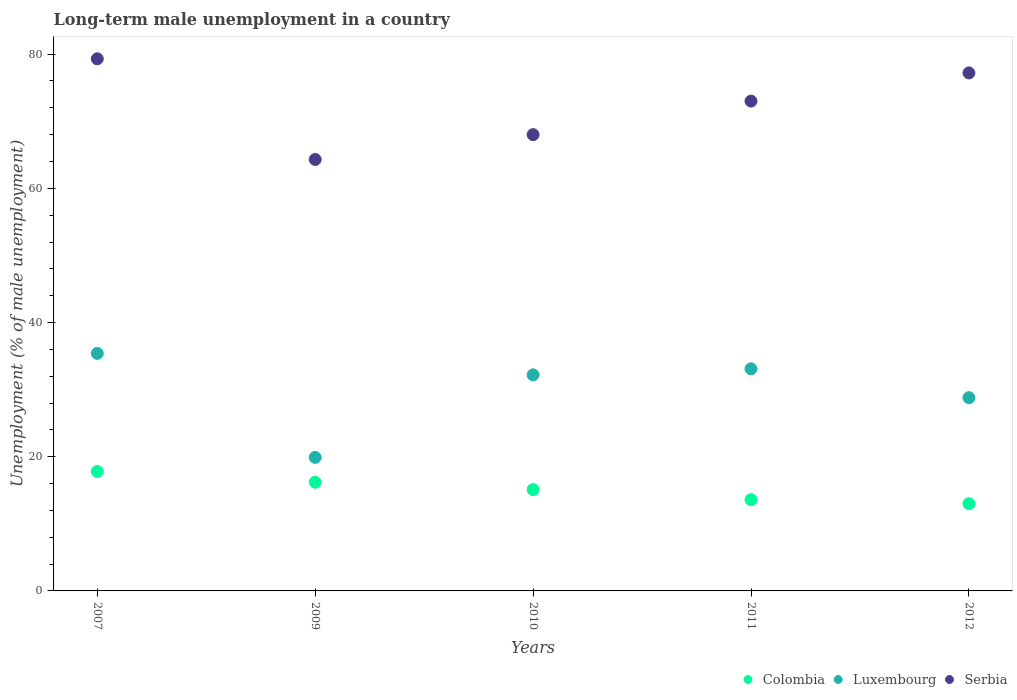Across all years, what is the maximum percentage of long-term unemployed male population in Serbia?
Your answer should be very brief. 79.3. Across all years, what is the minimum percentage of long-term unemployed male population in Luxembourg?
Give a very brief answer. 19.9. In which year was the percentage of long-term unemployed male population in Luxembourg minimum?
Your response must be concise. 2009. What is the total percentage of long-term unemployed male population in Colombia in the graph?
Your answer should be compact. 75.7. What is the difference between the percentage of long-term unemployed male population in Luxembourg in 2009 and that in 2012?
Make the answer very short. -8.9. What is the difference between the percentage of long-term unemployed male population in Colombia in 2011 and the percentage of long-term unemployed male population in Serbia in 2012?
Keep it short and to the point. -63.6. What is the average percentage of long-term unemployed male population in Luxembourg per year?
Ensure brevity in your answer.  29.88. In the year 2010, what is the difference between the percentage of long-term unemployed male population in Luxembourg and percentage of long-term unemployed male population in Serbia?
Your answer should be very brief. -35.8. What is the ratio of the percentage of long-term unemployed male population in Serbia in 2009 to that in 2011?
Your answer should be very brief. 0.88. Is the percentage of long-term unemployed male population in Colombia in 2007 less than that in 2012?
Your answer should be compact. No. Is the difference between the percentage of long-term unemployed male population in Luxembourg in 2009 and 2010 greater than the difference between the percentage of long-term unemployed male population in Serbia in 2009 and 2010?
Ensure brevity in your answer.  No. What is the difference between the highest and the second highest percentage of long-term unemployed male population in Colombia?
Your answer should be very brief. 1.6. What is the difference between the highest and the lowest percentage of long-term unemployed male population in Serbia?
Ensure brevity in your answer.  15. Is the sum of the percentage of long-term unemployed male population in Luxembourg in 2009 and 2010 greater than the maximum percentage of long-term unemployed male population in Serbia across all years?
Offer a very short reply. No. Is it the case that in every year, the sum of the percentage of long-term unemployed male population in Serbia and percentage of long-term unemployed male population in Colombia  is greater than the percentage of long-term unemployed male population in Luxembourg?
Ensure brevity in your answer.  Yes. What is the difference between two consecutive major ticks on the Y-axis?
Offer a very short reply. 20. Are the values on the major ticks of Y-axis written in scientific E-notation?
Provide a short and direct response. No. Does the graph contain grids?
Make the answer very short. No. Where does the legend appear in the graph?
Offer a very short reply. Bottom right. How many legend labels are there?
Provide a succinct answer. 3. How are the legend labels stacked?
Your answer should be compact. Horizontal. What is the title of the graph?
Give a very brief answer. Long-term male unemployment in a country. Does "Norway" appear as one of the legend labels in the graph?
Provide a short and direct response. No. What is the label or title of the Y-axis?
Make the answer very short. Unemployment (% of male unemployment). What is the Unemployment (% of male unemployment) in Colombia in 2007?
Give a very brief answer. 17.8. What is the Unemployment (% of male unemployment) in Luxembourg in 2007?
Your response must be concise. 35.4. What is the Unemployment (% of male unemployment) of Serbia in 2007?
Your answer should be compact. 79.3. What is the Unemployment (% of male unemployment) of Colombia in 2009?
Give a very brief answer. 16.2. What is the Unemployment (% of male unemployment) in Luxembourg in 2009?
Offer a terse response. 19.9. What is the Unemployment (% of male unemployment) of Serbia in 2009?
Provide a succinct answer. 64.3. What is the Unemployment (% of male unemployment) in Colombia in 2010?
Your response must be concise. 15.1. What is the Unemployment (% of male unemployment) of Luxembourg in 2010?
Offer a terse response. 32.2. What is the Unemployment (% of male unemployment) of Colombia in 2011?
Make the answer very short. 13.6. What is the Unemployment (% of male unemployment) in Luxembourg in 2011?
Provide a short and direct response. 33.1. What is the Unemployment (% of male unemployment) in Serbia in 2011?
Ensure brevity in your answer.  73. What is the Unemployment (% of male unemployment) of Colombia in 2012?
Keep it short and to the point. 13. What is the Unemployment (% of male unemployment) in Luxembourg in 2012?
Your answer should be compact. 28.8. What is the Unemployment (% of male unemployment) in Serbia in 2012?
Make the answer very short. 77.2. Across all years, what is the maximum Unemployment (% of male unemployment) in Colombia?
Offer a very short reply. 17.8. Across all years, what is the maximum Unemployment (% of male unemployment) of Luxembourg?
Offer a terse response. 35.4. Across all years, what is the maximum Unemployment (% of male unemployment) of Serbia?
Ensure brevity in your answer.  79.3. Across all years, what is the minimum Unemployment (% of male unemployment) in Colombia?
Your answer should be very brief. 13. Across all years, what is the minimum Unemployment (% of male unemployment) in Luxembourg?
Keep it short and to the point. 19.9. Across all years, what is the minimum Unemployment (% of male unemployment) of Serbia?
Ensure brevity in your answer.  64.3. What is the total Unemployment (% of male unemployment) in Colombia in the graph?
Offer a very short reply. 75.7. What is the total Unemployment (% of male unemployment) of Luxembourg in the graph?
Provide a succinct answer. 149.4. What is the total Unemployment (% of male unemployment) in Serbia in the graph?
Offer a very short reply. 361.8. What is the difference between the Unemployment (% of male unemployment) of Colombia in 2007 and that in 2009?
Ensure brevity in your answer.  1.6. What is the difference between the Unemployment (% of male unemployment) in Serbia in 2007 and that in 2009?
Ensure brevity in your answer.  15. What is the difference between the Unemployment (% of male unemployment) of Colombia in 2007 and that in 2010?
Keep it short and to the point. 2.7. What is the difference between the Unemployment (% of male unemployment) of Luxembourg in 2007 and that in 2010?
Offer a very short reply. 3.2. What is the difference between the Unemployment (% of male unemployment) in Serbia in 2007 and that in 2010?
Offer a very short reply. 11.3. What is the difference between the Unemployment (% of male unemployment) in Luxembourg in 2007 and that in 2011?
Offer a very short reply. 2.3. What is the difference between the Unemployment (% of male unemployment) of Serbia in 2007 and that in 2012?
Offer a terse response. 2.1. What is the difference between the Unemployment (% of male unemployment) of Luxembourg in 2009 and that in 2011?
Provide a short and direct response. -13.2. What is the difference between the Unemployment (% of male unemployment) in Serbia in 2009 and that in 2011?
Make the answer very short. -8.7. What is the difference between the Unemployment (% of male unemployment) of Luxembourg in 2010 and that in 2011?
Offer a very short reply. -0.9. What is the difference between the Unemployment (% of male unemployment) in Serbia in 2010 and that in 2011?
Keep it short and to the point. -5. What is the difference between the Unemployment (% of male unemployment) in Luxembourg in 2010 and that in 2012?
Your response must be concise. 3.4. What is the difference between the Unemployment (% of male unemployment) in Colombia in 2011 and that in 2012?
Provide a short and direct response. 0.6. What is the difference between the Unemployment (% of male unemployment) of Luxembourg in 2011 and that in 2012?
Provide a short and direct response. 4.3. What is the difference between the Unemployment (% of male unemployment) of Serbia in 2011 and that in 2012?
Give a very brief answer. -4.2. What is the difference between the Unemployment (% of male unemployment) in Colombia in 2007 and the Unemployment (% of male unemployment) in Luxembourg in 2009?
Your answer should be very brief. -2.1. What is the difference between the Unemployment (% of male unemployment) of Colombia in 2007 and the Unemployment (% of male unemployment) of Serbia in 2009?
Ensure brevity in your answer.  -46.5. What is the difference between the Unemployment (% of male unemployment) in Luxembourg in 2007 and the Unemployment (% of male unemployment) in Serbia in 2009?
Keep it short and to the point. -28.9. What is the difference between the Unemployment (% of male unemployment) in Colombia in 2007 and the Unemployment (% of male unemployment) in Luxembourg in 2010?
Your answer should be compact. -14.4. What is the difference between the Unemployment (% of male unemployment) in Colombia in 2007 and the Unemployment (% of male unemployment) in Serbia in 2010?
Offer a very short reply. -50.2. What is the difference between the Unemployment (% of male unemployment) in Luxembourg in 2007 and the Unemployment (% of male unemployment) in Serbia in 2010?
Keep it short and to the point. -32.6. What is the difference between the Unemployment (% of male unemployment) of Colombia in 2007 and the Unemployment (% of male unemployment) of Luxembourg in 2011?
Offer a very short reply. -15.3. What is the difference between the Unemployment (% of male unemployment) of Colombia in 2007 and the Unemployment (% of male unemployment) of Serbia in 2011?
Provide a short and direct response. -55.2. What is the difference between the Unemployment (% of male unemployment) of Luxembourg in 2007 and the Unemployment (% of male unemployment) of Serbia in 2011?
Offer a terse response. -37.6. What is the difference between the Unemployment (% of male unemployment) in Colombia in 2007 and the Unemployment (% of male unemployment) in Serbia in 2012?
Offer a terse response. -59.4. What is the difference between the Unemployment (% of male unemployment) of Luxembourg in 2007 and the Unemployment (% of male unemployment) of Serbia in 2012?
Your answer should be compact. -41.8. What is the difference between the Unemployment (% of male unemployment) of Colombia in 2009 and the Unemployment (% of male unemployment) of Serbia in 2010?
Make the answer very short. -51.8. What is the difference between the Unemployment (% of male unemployment) of Luxembourg in 2009 and the Unemployment (% of male unemployment) of Serbia in 2010?
Offer a terse response. -48.1. What is the difference between the Unemployment (% of male unemployment) in Colombia in 2009 and the Unemployment (% of male unemployment) in Luxembourg in 2011?
Offer a very short reply. -16.9. What is the difference between the Unemployment (% of male unemployment) of Colombia in 2009 and the Unemployment (% of male unemployment) of Serbia in 2011?
Your response must be concise. -56.8. What is the difference between the Unemployment (% of male unemployment) in Luxembourg in 2009 and the Unemployment (% of male unemployment) in Serbia in 2011?
Keep it short and to the point. -53.1. What is the difference between the Unemployment (% of male unemployment) of Colombia in 2009 and the Unemployment (% of male unemployment) of Serbia in 2012?
Provide a succinct answer. -61. What is the difference between the Unemployment (% of male unemployment) of Luxembourg in 2009 and the Unemployment (% of male unemployment) of Serbia in 2012?
Ensure brevity in your answer.  -57.3. What is the difference between the Unemployment (% of male unemployment) of Colombia in 2010 and the Unemployment (% of male unemployment) of Luxembourg in 2011?
Ensure brevity in your answer.  -18. What is the difference between the Unemployment (% of male unemployment) in Colombia in 2010 and the Unemployment (% of male unemployment) in Serbia in 2011?
Your answer should be very brief. -57.9. What is the difference between the Unemployment (% of male unemployment) in Luxembourg in 2010 and the Unemployment (% of male unemployment) in Serbia in 2011?
Make the answer very short. -40.8. What is the difference between the Unemployment (% of male unemployment) of Colombia in 2010 and the Unemployment (% of male unemployment) of Luxembourg in 2012?
Ensure brevity in your answer.  -13.7. What is the difference between the Unemployment (% of male unemployment) of Colombia in 2010 and the Unemployment (% of male unemployment) of Serbia in 2012?
Provide a short and direct response. -62.1. What is the difference between the Unemployment (% of male unemployment) in Luxembourg in 2010 and the Unemployment (% of male unemployment) in Serbia in 2012?
Your answer should be very brief. -45. What is the difference between the Unemployment (% of male unemployment) in Colombia in 2011 and the Unemployment (% of male unemployment) in Luxembourg in 2012?
Your response must be concise. -15.2. What is the difference between the Unemployment (% of male unemployment) in Colombia in 2011 and the Unemployment (% of male unemployment) in Serbia in 2012?
Offer a very short reply. -63.6. What is the difference between the Unemployment (% of male unemployment) of Luxembourg in 2011 and the Unemployment (% of male unemployment) of Serbia in 2012?
Your answer should be very brief. -44.1. What is the average Unemployment (% of male unemployment) in Colombia per year?
Provide a short and direct response. 15.14. What is the average Unemployment (% of male unemployment) in Luxembourg per year?
Your answer should be very brief. 29.88. What is the average Unemployment (% of male unemployment) of Serbia per year?
Your response must be concise. 72.36. In the year 2007, what is the difference between the Unemployment (% of male unemployment) in Colombia and Unemployment (% of male unemployment) in Luxembourg?
Offer a terse response. -17.6. In the year 2007, what is the difference between the Unemployment (% of male unemployment) of Colombia and Unemployment (% of male unemployment) of Serbia?
Your response must be concise. -61.5. In the year 2007, what is the difference between the Unemployment (% of male unemployment) of Luxembourg and Unemployment (% of male unemployment) of Serbia?
Ensure brevity in your answer.  -43.9. In the year 2009, what is the difference between the Unemployment (% of male unemployment) in Colombia and Unemployment (% of male unemployment) in Luxembourg?
Keep it short and to the point. -3.7. In the year 2009, what is the difference between the Unemployment (% of male unemployment) in Colombia and Unemployment (% of male unemployment) in Serbia?
Your answer should be very brief. -48.1. In the year 2009, what is the difference between the Unemployment (% of male unemployment) in Luxembourg and Unemployment (% of male unemployment) in Serbia?
Offer a very short reply. -44.4. In the year 2010, what is the difference between the Unemployment (% of male unemployment) in Colombia and Unemployment (% of male unemployment) in Luxembourg?
Ensure brevity in your answer.  -17.1. In the year 2010, what is the difference between the Unemployment (% of male unemployment) in Colombia and Unemployment (% of male unemployment) in Serbia?
Ensure brevity in your answer.  -52.9. In the year 2010, what is the difference between the Unemployment (% of male unemployment) in Luxembourg and Unemployment (% of male unemployment) in Serbia?
Offer a terse response. -35.8. In the year 2011, what is the difference between the Unemployment (% of male unemployment) of Colombia and Unemployment (% of male unemployment) of Luxembourg?
Your answer should be compact. -19.5. In the year 2011, what is the difference between the Unemployment (% of male unemployment) in Colombia and Unemployment (% of male unemployment) in Serbia?
Offer a very short reply. -59.4. In the year 2011, what is the difference between the Unemployment (% of male unemployment) in Luxembourg and Unemployment (% of male unemployment) in Serbia?
Your answer should be compact. -39.9. In the year 2012, what is the difference between the Unemployment (% of male unemployment) of Colombia and Unemployment (% of male unemployment) of Luxembourg?
Give a very brief answer. -15.8. In the year 2012, what is the difference between the Unemployment (% of male unemployment) in Colombia and Unemployment (% of male unemployment) in Serbia?
Ensure brevity in your answer.  -64.2. In the year 2012, what is the difference between the Unemployment (% of male unemployment) of Luxembourg and Unemployment (% of male unemployment) of Serbia?
Offer a terse response. -48.4. What is the ratio of the Unemployment (% of male unemployment) of Colombia in 2007 to that in 2009?
Make the answer very short. 1.1. What is the ratio of the Unemployment (% of male unemployment) of Luxembourg in 2007 to that in 2009?
Offer a terse response. 1.78. What is the ratio of the Unemployment (% of male unemployment) in Serbia in 2007 to that in 2009?
Your response must be concise. 1.23. What is the ratio of the Unemployment (% of male unemployment) in Colombia in 2007 to that in 2010?
Provide a short and direct response. 1.18. What is the ratio of the Unemployment (% of male unemployment) of Luxembourg in 2007 to that in 2010?
Keep it short and to the point. 1.1. What is the ratio of the Unemployment (% of male unemployment) of Serbia in 2007 to that in 2010?
Your answer should be compact. 1.17. What is the ratio of the Unemployment (% of male unemployment) in Colombia in 2007 to that in 2011?
Offer a very short reply. 1.31. What is the ratio of the Unemployment (% of male unemployment) in Luxembourg in 2007 to that in 2011?
Give a very brief answer. 1.07. What is the ratio of the Unemployment (% of male unemployment) in Serbia in 2007 to that in 2011?
Your answer should be very brief. 1.09. What is the ratio of the Unemployment (% of male unemployment) in Colombia in 2007 to that in 2012?
Provide a short and direct response. 1.37. What is the ratio of the Unemployment (% of male unemployment) in Luxembourg in 2007 to that in 2012?
Offer a very short reply. 1.23. What is the ratio of the Unemployment (% of male unemployment) in Serbia in 2007 to that in 2012?
Your response must be concise. 1.03. What is the ratio of the Unemployment (% of male unemployment) in Colombia in 2009 to that in 2010?
Your answer should be compact. 1.07. What is the ratio of the Unemployment (% of male unemployment) in Luxembourg in 2009 to that in 2010?
Ensure brevity in your answer.  0.62. What is the ratio of the Unemployment (% of male unemployment) in Serbia in 2009 to that in 2010?
Your answer should be compact. 0.95. What is the ratio of the Unemployment (% of male unemployment) in Colombia in 2009 to that in 2011?
Keep it short and to the point. 1.19. What is the ratio of the Unemployment (% of male unemployment) of Luxembourg in 2009 to that in 2011?
Ensure brevity in your answer.  0.6. What is the ratio of the Unemployment (% of male unemployment) in Serbia in 2009 to that in 2011?
Keep it short and to the point. 0.88. What is the ratio of the Unemployment (% of male unemployment) in Colombia in 2009 to that in 2012?
Offer a very short reply. 1.25. What is the ratio of the Unemployment (% of male unemployment) in Luxembourg in 2009 to that in 2012?
Your response must be concise. 0.69. What is the ratio of the Unemployment (% of male unemployment) of Serbia in 2009 to that in 2012?
Provide a succinct answer. 0.83. What is the ratio of the Unemployment (% of male unemployment) of Colombia in 2010 to that in 2011?
Provide a short and direct response. 1.11. What is the ratio of the Unemployment (% of male unemployment) of Luxembourg in 2010 to that in 2011?
Offer a terse response. 0.97. What is the ratio of the Unemployment (% of male unemployment) of Serbia in 2010 to that in 2011?
Make the answer very short. 0.93. What is the ratio of the Unemployment (% of male unemployment) of Colombia in 2010 to that in 2012?
Make the answer very short. 1.16. What is the ratio of the Unemployment (% of male unemployment) of Luxembourg in 2010 to that in 2012?
Give a very brief answer. 1.12. What is the ratio of the Unemployment (% of male unemployment) in Serbia in 2010 to that in 2012?
Offer a terse response. 0.88. What is the ratio of the Unemployment (% of male unemployment) in Colombia in 2011 to that in 2012?
Ensure brevity in your answer.  1.05. What is the ratio of the Unemployment (% of male unemployment) in Luxembourg in 2011 to that in 2012?
Give a very brief answer. 1.15. What is the ratio of the Unemployment (% of male unemployment) of Serbia in 2011 to that in 2012?
Offer a terse response. 0.95. What is the difference between the highest and the second highest Unemployment (% of male unemployment) in Colombia?
Your answer should be compact. 1.6. What is the difference between the highest and the lowest Unemployment (% of male unemployment) of Luxembourg?
Offer a very short reply. 15.5. What is the difference between the highest and the lowest Unemployment (% of male unemployment) in Serbia?
Your answer should be very brief. 15. 